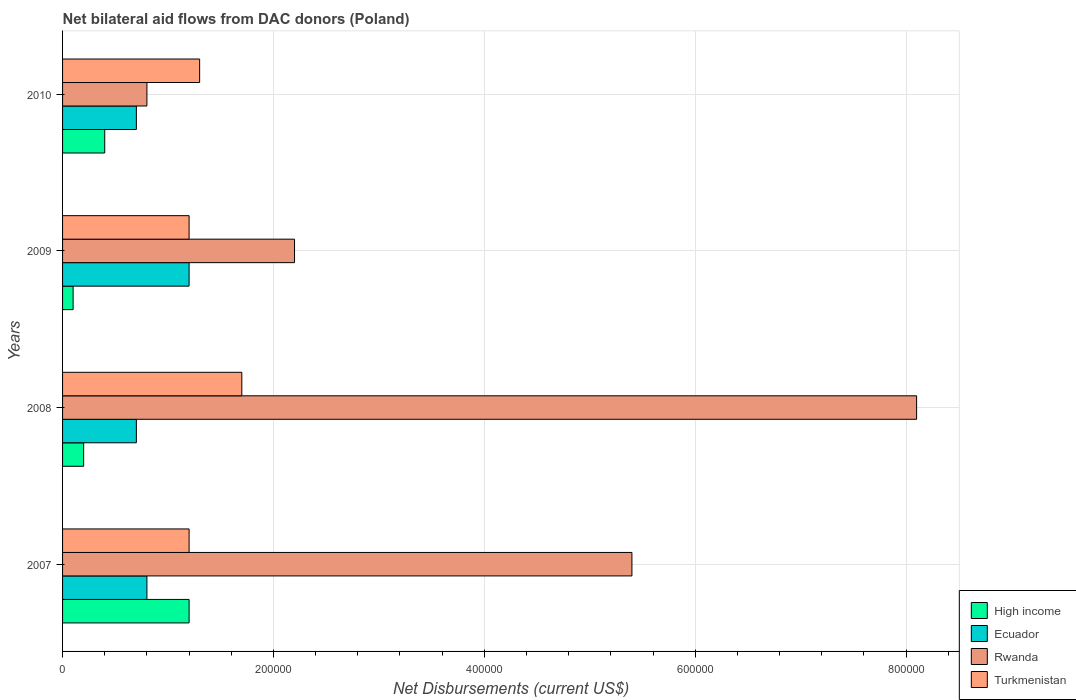How many different coloured bars are there?
Provide a short and direct response. 4. Are the number of bars on each tick of the Y-axis equal?
Offer a very short reply. Yes. How many bars are there on the 4th tick from the top?
Make the answer very short. 4. How many bars are there on the 2nd tick from the bottom?
Provide a short and direct response. 4. In how many cases, is the number of bars for a given year not equal to the number of legend labels?
Keep it short and to the point. 0. What is the net bilateral aid flows in High income in 2009?
Provide a succinct answer. 10000. Across all years, what is the maximum net bilateral aid flows in Turkmenistan?
Your answer should be compact. 1.70e+05. In which year was the net bilateral aid flows in Rwanda minimum?
Your answer should be compact. 2010. What is the total net bilateral aid flows in Ecuador in the graph?
Offer a terse response. 3.40e+05. What is the difference between the net bilateral aid flows in Turkmenistan in 2007 and that in 2010?
Give a very brief answer. -10000. What is the difference between the net bilateral aid flows in High income in 2009 and the net bilateral aid flows in Rwanda in 2008?
Make the answer very short. -8.00e+05. What is the average net bilateral aid flows in Ecuador per year?
Offer a terse response. 8.50e+04. In the year 2007, what is the difference between the net bilateral aid flows in Ecuador and net bilateral aid flows in High income?
Ensure brevity in your answer.  -4.00e+04. In how many years, is the net bilateral aid flows in Ecuador greater than 680000 US$?
Offer a terse response. 0. What is the ratio of the net bilateral aid flows in Ecuador in 2007 to that in 2008?
Offer a very short reply. 1.14. Is the net bilateral aid flows in Turkmenistan in 2007 less than that in 2010?
Offer a terse response. Yes. Is the difference between the net bilateral aid flows in Ecuador in 2009 and 2010 greater than the difference between the net bilateral aid flows in High income in 2009 and 2010?
Your answer should be very brief. Yes. What is the difference between the highest and the second highest net bilateral aid flows in Rwanda?
Make the answer very short. 2.70e+05. What is the difference between the highest and the lowest net bilateral aid flows in High income?
Make the answer very short. 1.10e+05. Is the sum of the net bilateral aid flows in Turkmenistan in 2007 and 2008 greater than the maximum net bilateral aid flows in Ecuador across all years?
Keep it short and to the point. Yes. Is it the case that in every year, the sum of the net bilateral aid flows in High income and net bilateral aid flows in Rwanda is greater than the sum of net bilateral aid flows in Turkmenistan and net bilateral aid flows in Ecuador?
Offer a very short reply. Yes. What does the 1st bar from the top in 2009 represents?
Your answer should be compact. Turkmenistan. Is it the case that in every year, the sum of the net bilateral aid flows in Turkmenistan and net bilateral aid flows in Rwanda is greater than the net bilateral aid flows in High income?
Ensure brevity in your answer.  Yes. How many bars are there?
Ensure brevity in your answer.  16. Are all the bars in the graph horizontal?
Your answer should be compact. Yes. What is the difference between two consecutive major ticks on the X-axis?
Provide a short and direct response. 2.00e+05. Are the values on the major ticks of X-axis written in scientific E-notation?
Your answer should be very brief. No. Does the graph contain grids?
Offer a terse response. Yes. How are the legend labels stacked?
Your answer should be very brief. Vertical. What is the title of the graph?
Provide a short and direct response. Net bilateral aid flows from DAC donors (Poland). Does "Serbia" appear as one of the legend labels in the graph?
Your answer should be compact. No. What is the label or title of the X-axis?
Keep it short and to the point. Net Disbursements (current US$). What is the label or title of the Y-axis?
Your answer should be very brief. Years. What is the Net Disbursements (current US$) in Rwanda in 2007?
Provide a short and direct response. 5.40e+05. What is the Net Disbursements (current US$) of Turkmenistan in 2007?
Your answer should be very brief. 1.20e+05. What is the Net Disbursements (current US$) of High income in 2008?
Your answer should be compact. 2.00e+04. What is the Net Disbursements (current US$) in Rwanda in 2008?
Offer a terse response. 8.10e+05. What is the Net Disbursements (current US$) in High income in 2009?
Ensure brevity in your answer.  10000. What is the Net Disbursements (current US$) in Ecuador in 2009?
Provide a short and direct response. 1.20e+05. What is the Net Disbursements (current US$) in Turkmenistan in 2009?
Ensure brevity in your answer.  1.20e+05. What is the Net Disbursements (current US$) in Ecuador in 2010?
Offer a very short reply. 7.00e+04. Across all years, what is the maximum Net Disbursements (current US$) in Ecuador?
Give a very brief answer. 1.20e+05. Across all years, what is the maximum Net Disbursements (current US$) of Rwanda?
Ensure brevity in your answer.  8.10e+05. Across all years, what is the minimum Net Disbursements (current US$) of High income?
Give a very brief answer. 10000. Across all years, what is the minimum Net Disbursements (current US$) of Ecuador?
Keep it short and to the point. 7.00e+04. Across all years, what is the minimum Net Disbursements (current US$) of Rwanda?
Provide a short and direct response. 8.00e+04. Across all years, what is the minimum Net Disbursements (current US$) in Turkmenistan?
Your answer should be very brief. 1.20e+05. What is the total Net Disbursements (current US$) of High income in the graph?
Offer a very short reply. 1.90e+05. What is the total Net Disbursements (current US$) of Rwanda in the graph?
Provide a short and direct response. 1.65e+06. What is the total Net Disbursements (current US$) in Turkmenistan in the graph?
Provide a short and direct response. 5.40e+05. What is the difference between the Net Disbursements (current US$) of Rwanda in 2007 and that in 2008?
Provide a succinct answer. -2.70e+05. What is the difference between the Net Disbursements (current US$) of Turkmenistan in 2007 and that in 2008?
Keep it short and to the point. -5.00e+04. What is the difference between the Net Disbursements (current US$) in High income in 2007 and that in 2009?
Offer a very short reply. 1.10e+05. What is the difference between the Net Disbursements (current US$) in Rwanda in 2007 and that in 2009?
Offer a terse response. 3.20e+05. What is the difference between the Net Disbursements (current US$) of Turkmenistan in 2007 and that in 2009?
Offer a terse response. 0. What is the difference between the Net Disbursements (current US$) of High income in 2007 and that in 2010?
Your response must be concise. 8.00e+04. What is the difference between the Net Disbursements (current US$) in Ecuador in 2008 and that in 2009?
Your answer should be compact. -5.00e+04. What is the difference between the Net Disbursements (current US$) in Rwanda in 2008 and that in 2009?
Offer a terse response. 5.90e+05. What is the difference between the Net Disbursements (current US$) in Turkmenistan in 2008 and that in 2009?
Make the answer very short. 5.00e+04. What is the difference between the Net Disbursements (current US$) in Rwanda in 2008 and that in 2010?
Provide a short and direct response. 7.30e+05. What is the difference between the Net Disbursements (current US$) of Turkmenistan in 2008 and that in 2010?
Your response must be concise. 4.00e+04. What is the difference between the Net Disbursements (current US$) in Ecuador in 2009 and that in 2010?
Make the answer very short. 5.00e+04. What is the difference between the Net Disbursements (current US$) of Turkmenistan in 2009 and that in 2010?
Offer a very short reply. -10000. What is the difference between the Net Disbursements (current US$) of High income in 2007 and the Net Disbursements (current US$) of Ecuador in 2008?
Offer a terse response. 5.00e+04. What is the difference between the Net Disbursements (current US$) of High income in 2007 and the Net Disbursements (current US$) of Rwanda in 2008?
Your answer should be compact. -6.90e+05. What is the difference between the Net Disbursements (current US$) of High income in 2007 and the Net Disbursements (current US$) of Turkmenistan in 2008?
Offer a very short reply. -5.00e+04. What is the difference between the Net Disbursements (current US$) in Ecuador in 2007 and the Net Disbursements (current US$) in Rwanda in 2008?
Provide a succinct answer. -7.30e+05. What is the difference between the Net Disbursements (current US$) in Ecuador in 2007 and the Net Disbursements (current US$) in Turkmenistan in 2008?
Offer a terse response. -9.00e+04. What is the difference between the Net Disbursements (current US$) of Rwanda in 2007 and the Net Disbursements (current US$) of Turkmenistan in 2008?
Ensure brevity in your answer.  3.70e+05. What is the difference between the Net Disbursements (current US$) of High income in 2007 and the Net Disbursements (current US$) of Ecuador in 2009?
Ensure brevity in your answer.  0. What is the difference between the Net Disbursements (current US$) of High income in 2007 and the Net Disbursements (current US$) of Rwanda in 2009?
Offer a terse response. -1.00e+05. What is the difference between the Net Disbursements (current US$) in Ecuador in 2007 and the Net Disbursements (current US$) in Rwanda in 2009?
Offer a terse response. -1.40e+05. What is the difference between the Net Disbursements (current US$) in Ecuador in 2007 and the Net Disbursements (current US$) in Turkmenistan in 2009?
Ensure brevity in your answer.  -4.00e+04. What is the difference between the Net Disbursements (current US$) in Rwanda in 2007 and the Net Disbursements (current US$) in Turkmenistan in 2009?
Keep it short and to the point. 4.20e+05. What is the difference between the Net Disbursements (current US$) of High income in 2007 and the Net Disbursements (current US$) of Turkmenistan in 2010?
Offer a terse response. -10000. What is the difference between the Net Disbursements (current US$) of Ecuador in 2007 and the Net Disbursements (current US$) of Rwanda in 2010?
Provide a succinct answer. 0. What is the difference between the Net Disbursements (current US$) in Rwanda in 2007 and the Net Disbursements (current US$) in Turkmenistan in 2010?
Your response must be concise. 4.10e+05. What is the difference between the Net Disbursements (current US$) of High income in 2008 and the Net Disbursements (current US$) of Rwanda in 2009?
Provide a short and direct response. -2.00e+05. What is the difference between the Net Disbursements (current US$) in Ecuador in 2008 and the Net Disbursements (current US$) in Rwanda in 2009?
Ensure brevity in your answer.  -1.50e+05. What is the difference between the Net Disbursements (current US$) in Rwanda in 2008 and the Net Disbursements (current US$) in Turkmenistan in 2009?
Provide a short and direct response. 6.90e+05. What is the difference between the Net Disbursements (current US$) of High income in 2008 and the Net Disbursements (current US$) of Ecuador in 2010?
Provide a short and direct response. -5.00e+04. What is the difference between the Net Disbursements (current US$) of High income in 2008 and the Net Disbursements (current US$) of Rwanda in 2010?
Your answer should be very brief. -6.00e+04. What is the difference between the Net Disbursements (current US$) in Ecuador in 2008 and the Net Disbursements (current US$) in Rwanda in 2010?
Your response must be concise. -10000. What is the difference between the Net Disbursements (current US$) of Ecuador in 2008 and the Net Disbursements (current US$) of Turkmenistan in 2010?
Your answer should be compact. -6.00e+04. What is the difference between the Net Disbursements (current US$) of Rwanda in 2008 and the Net Disbursements (current US$) of Turkmenistan in 2010?
Your answer should be compact. 6.80e+05. What is the difference between the Net Disbursements (current US$) in High income in 2009 and the Net Disbursements (current US$) in Ecuador in 2010?
Your answer should be very brief. -6.00e+04. What is the difference between the Net Disbursements (current US$) of High income in 2009 and the Net Disbursements (current US$) of Turkmenistan in 2010?
Ensure brevity in your answer.  -1.20e+05. What is the difference between the Net Disbursements (current US$) in Ecuador in 2009 and the Net Disbursements (current US$) in Rwanda in 2010?
Your response must be concise. 4.00e+04. What is the difference between the Net Disbursements (current US$) of Ecuador in 2009 and the Net Disbursements (current US$) of Turkmenistan in 2010?
Give a very brief answer. -10000. What is the difference between the Net Disbursements (current US$) of Rwanda in 2009 and the Net Disbursements (current US$) of Turkmenistan in 2010?
Your answer should be compact. 9.00e+04. What is the average Net Disbursements (current US$) of High income per year?
Offer a terse response. 4.75e+04. What is the average Net Disbursements (current US$) in Ecuador per year?
Provide a short and direct response. 8.50e+04. What is the average Net Disbursements (current US$) in Rwanda per year?
Offer a very short reply. 4.12e+05. What is the average Net Disbursements (current US$) in Turkmenistan per year?
Your answer should be very brief. 1.35e+05. In the year 2007, what is the difference between the Net Disbursements (current US$) in High income and Net Disbursements (current US$) in Ecuador?
Ensure brevity in your answer.  4.00e+04. In the year 2007, what is the difference between the Net Disbursements (current US$) in High income and Net Disbursements (current US$) in Rwanda?
Your answer should be compact. -4.20e+05. In the year 2007, what is the difference between the Net Disbursements (current US$) in High income and Net Disbursements (current US$) in Turkmenistan?
Provide a short and direct response. 0. In the year 2007, what is the difference between the Net Disbursements (current US$) of Ecuador and Net Disbursements (current US$) of Rwanda?
Your response must be concise. -4.60e+05. In the year 2008, what is the difference between the Net Disbursements (current US$) of High income and Net Disbursements (current US$) of Ecuador?
Your answer should be compact. -5.00e+04. In the year 2008, what is the difference between the Net Disbursements (current US$) in High income and Net Disbursements (current US$) in Rwanda?
Make the answer very short. -7.90e+05. In the year 2008, what is the difference between the Net Disbursements (current US$) of High income and Net Disbursements (current US$) of Turkmenistan?
Keep it short and to the point. -1.50e+05. In the year 2008, what is the difference between the Net Disbursements (current US$) in Ecuador and Net Disbursements (current US$) in Rwanda?
Ensure brevity in your answer.  -7.40e+05. In the year 2008, what is the difference between the Net Disbursements (current US$) in Ecuador and Net Disbursements (current US$) in Turkmenistan?
Your answer should be very brief. -1.00e+05. In the year 2008, what is the difference between the Net Disbursements (current US$) in Rwanda and Net Disbursements (current US$) in Turkmenistan?
Make the answer very short. 6.40e+05. In the year 2009, what is the difference between the Net Disbursements (current US$) of High income and Net Disbursements (current US$) of Ecuador?
Provide a short and direct response. -1.10e+05. In the year 2009, what is the difference between the Net Disbursements (current US$) of Ecuador and Net Disbursements (current US$) of Rwanda?
Provide a succinct answer. -1.00e+05. In the year 2010, what is the difference between the Net Disbursements (current US$) in High income and Net Disbursements (current US$) in Ecuador?
Provide a succinct answer. -3.00e+04. In the year 2010, what is the difference between the Net Disbursements (current US$) in Ecuador and Net Disbursements (current US$) in Turkmenistan?
Offer a very short reply. -6.00e+04. What is the ratio of the Net Disbursements (current US$) in Ecuador in 2007 to that in 2008?
Your response must be concise. 1.14. What is the ratio of the Net Disbursements (current US$) of Turkmenistan in 2007 to that in 2008?
Provide a short and direct response. 0.71. What is the ratio of the Net Disbursements (current US$) of Ecuador in 2007 to that in 2009?
Offer a very short reply. 0.67. What is the ratio of the Net Disbursements (current US$) in Rwanda in 2007 to that in 2009?
Your response must be concise. 2.45. What is the ratio of the Net Disbursements (current US$) in Turkmenistan in 2007 to that in 2009?
Give a very brief answer. 1. What is the ratio of the Net Disbursements (current US$) of Rwanda in 2007 to that in 2010?
Your answer should be compact. 6.75. What is the ratio of the Net Disbursements (current US$) of Turkmenistan in 2007 to that in 2010?
Provide a short and direct response. 0.92. What is the ratio of the Net Disbursements (current US$) in Ecuador in 2008 to that in 2009?
Provide a short and direct response. 0.58. What is the ratio of the Net Disbursements (current US$) in Rwanda in 2008 to that in 2009?
Your answer should be compact. 3.68. What is the ratio of the Net Disbursements (current US$) of Turkmenistan in 2008 to that in 2009?
Provide a short and direct response. 1.42. What is the ratio of the Net Disbursements (current US$) in Rwanda in 2008 to that in 2010?
Ensure brevity in your answer.  10.12. What is the ratio of the Net Disbursements (current US$) of Turkmenistan in 2008 to that in 2010?
Make the answer very short. 1.31. What is the ratio of the Net Disbursements (current US$) of High income in 2009 to that in 2010?
Ensure brevity in your answer.  0.25. What is the ratio of the Net Disbursements (current US$) of Ecuador in 2009 to that in 2010?
Offer a very short reply. 1.71. What is the ratio of the Net Disbursements (current US$) of Rwanda in 2009 to that in 2010?
Provide a succinct answer. 2.75. What is the difference between the highest and the second highest Net Disbursements (current US$) in High income?
Keep it short and to the point. 8.00e+04. What is the difference between the highest and the lowest Net Disbursements (current US$) in Ecuador?
Provide a succinct answer. 5.00e+04. What is the difference between the highest and the lowest Net Disbursements (current US$) in Rwanda?
Offer a terse response. 7.30e+05. What is the difference between the highest and the lowest Net Disbursements (current US$) of Turkmenistan?
Keep it short and to the point. 5.00e+04. 